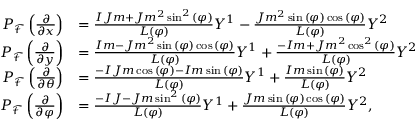<formula> <loc_0><loc_0><loc_500><loc_500>\begin{array} { r l } { P _ { \mathcal { F } } \left ( \frac { \partial } { \partial x } \right ) } & { = \frac { I J m + J m ^ { 2 } \sin ^ { 2 } { \left ( \varphi \right ) } } { L ( \varphi ) } Y ^ { 1 } - \frac { J m ^ { 2 } \sin { \left ( \varphi \right ) } \cos { \left ( \varphi \right ) } } { L ( \varphi ) } Y ^ { 2 } } \\ { P _ { \mathcal { F } } \left ( \frac { \partial } { \partial y } \right ) } & { = \frac { I m - J m ^ { 2 } \sin { \left ( \varphi \right ) } \cos { \left ( \varphi \right ) } } { L ( \varphi ) } Y ^ { 1 } + \frac { - I m + J m ^ { 2 } \cos ^ { 2 } { \left ( \varphi \right ) } } { L ( \varphi ) } Y ^ { 2 } } \\ { P _ { \mathcal { F } } \left ( \frac { \partial } { \partial \theta } \right ) } & { = \frac { - I J m \cos { \left ( \varphi \right ) } - I m \sin { \left ( \varphi \right ) } } { L ( \varphi ) } Y ^ { 1 } + \frac { I m \sin { \left ( \varphi \right ) } } { L ( \varphi ) } Y ^ { 2 } } \\ { P _ { \mathcal { F } } \left ( \frac { \partial } { \partial \varphi } \right ) } & { = \frac { - I J - J m \sin ^ { 2 } { \left ( \varphi \right ) } } { L ( \varphi ) } Y ^ { 1 } + \frac { J m \sin { \left ( \varphi \right ) } \cos { \left ( \varphi \right ) } } { L ( \varphi ) } Y ^ { 2 } , } \end{array}</formula> 